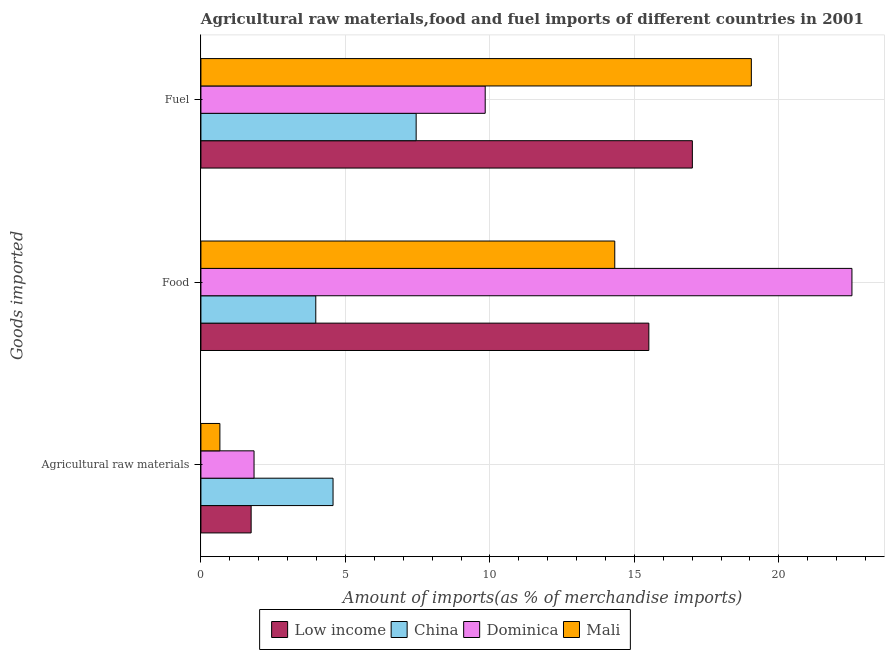How many bars are there on the 2nd tick from the bottom?
Your answer should be very brief. 4. What is the label of the 2nd group of bars from the top?
Your answer should be compact. Food. What is the percentage of food imports in China?
Provide a succinct answer. 3.97. Across all countries, what is the maximum percentage of food imports?
Keep it short and to the point. 22.53. Across all countries, what is the minimum percentage of food imports?
Your answer should be compact. 3.97. In which country was the percentage of food imports maximum?
Offer a terse response. Dominica. What is the total percentage of fuel imports in the graph?
Your response must be concise. 53.34. What is the difference between the percentage of fuel imports in Low income and that in Dominica?
Provide a succinct answer. 7.17. What is the difference between the percentage of fuel imports in Low income and the percentage of food imports in China?
Provide a short and direct response. 13.03. What is the average percentage of fuel imports per country?
Offer a very short reply. 13.33. What is the difference between the percentage of fuel imports and percentage of food imports in Dominica?
Keep it short and to the point. -12.69. What is the ratio of the percentage of fuel imports in Low income to that in China?
Offer a terse response. 2.28. Is the percentage of fuel imports in Dominica less than that in China?
Keep it short and to the point. No. Is the difference between the percentage of raw materials imports in Mali and Low income greater than the difference between the percentage of food imports in Mali and Low income?
Your answer should be compact. Yes. What is the difference between the highest and the second highest percentage of fuel imports?
Your answer should be compact. 2.04. What is the difference between the highest and the lowest percentage of food imports?
Your answer should be very brief. 18.55. Is the sum of the percentage of raw materials imports in China and Dominica greater than the maximum percentage of food imports across all countries?
Your response must be concise. No. What does the 1st bar from the top in Agricultural raw materials represents?
Provide a succinct answer. Mali. What does the 2nd bar from the bottom in Food represents?
Make the answer very short. China. Is it the case that in every country, the sum of the percentage of raw materials imports and percentage of food imports is greater than the percentage of fuel imports?
Your response must be concise. No. How many bars are there?
Your answer should be very brief. 12. Are all the bars in the graph horizontal?
Make the answer very short. Yes. How many countries are there in the graph?
Your answer should be very brief. 4. What is the difference between two consecutive major ticks on the X-axis?
Make the answer very short. 5. Are the values on the major ticks of X-axis written in scientific E-notation?
Give a very brief answer. No. Does the graph contain any zero values?
Keep it short and to the point. No. Does the graph contain grids?
Your answer should be compact. Yes. How are the legend labels stacked?
Keep it short and to the point. Horizontal. What is the title of the graph?
Offer a very short reply. Agricultural raw materials,food and fuel imports of different countries in 2001. What is the label or title of the X-axis?
Provide a short and direct response. Amount of imports(as % of merchandise imports). What is the label or title of the Y-axis?
Ensure brevity in your answer.  Goods imported. What is the Amount of imports(as % of merchandise imports) in Low income in Agricultural raw materials?
Offer a very short reply. 1.74. What is the Amount of imports(as % of merchandise imports) in China in Agricultural raw materials?
Make the answer very short. 4.57. What is the Amount of imports(as % of merchandise imports) in Dominica in Agricultural raw materials?
Make the answer very short. 1.84. What is the Amount of imports(as % of merchandise imports) in Mali in Agricultural raw materials?
Offer a terse response. 0.66. What is the Amount of imports(as % of merchandise imports) in Low income in Food?
Your answer should be very brief. 15.5. What is the Amount of imports(as % of merchandise imports) in China in Food?
Your answer should be very brief. 3.97. What is the Amount of imports(as % of merchandise imports) in Dominica in Food?
Your answer should be compact. 22.53. What is the Amount of imports(as % of merchandise imports) in Mali in Food?
Offer a terse response. 14.32. What is the Amount of imports(as % of merchandise imports) in Low income in Fuel?
Make the answer very short. 17.01. What is the Amount of imports(as % of merchandise imports) in China in Fuel?
Provide a succinct answer. 7.45. What is the Amount of imports(as % of merchandise imports) of Dominica in Fuel?
Offer a terse response. 9.84. What is the Amount of imports(as % of merchandise imports) of Mali in Fuel?
Offer a terse response. 19.05. Across all Goods imported, what is the maximum Amount of imports(as % of merchandise imports) in Low income?
Give a very brief answer. 17.01. Across all Goods imported, what is the maximum Amount of imports(as % of merchandise imports) in China?
Your response must be concise. 7.45. Across all Goods imported, what is the maximum Amount of imports(as % of merchandise imports) in Dominica?
Keep it short and to the point. 22.53. Across all Goods imported, what is the maximum Amount of imports(as % of merchandise imports) of Mali?
Offer a very short reply. 19.05. Across all Goods imported, what is the minimum Amount of imports(as % of merchandise imports) in Low income?
Provide a succinct answer. 1.74. Across all Goods imported, what is the minimum Amount of imports(as % of merchandise imports) of China?
Keep it short and to the point. 3.97. Across all Goods imported, what is the minimum Amount of imports(as % of merchandise imports) in Dominica?
Your response must be concise. 1.84. Across all Goods imported, what is the minimum Amount of imports(as % of merchandise imports) of Mali?
Offer a terse response. 0.66. What is the total Amount of imports(as % of merchandise imports) in Low income in the graph?
Give a very brief answer. 34.24. What is the total Amount of imports(as % of merchandise imports) in China in the graph?
Provide a succinct answer. 16. What is the total Amount of imports(as % of merchandise imports) in Dominica in the graph?
Your response must be concise. 34.2. What is the total Amount of imports(as % of merchandise imports) in Mali in the graph?
Your answer should be very brief. 34.02. What is the difference between the Amount of imports(as % of merchandise imports) of Low income in Agricultural raw materials and that in Food?
Keep it short and to the point. -13.76. What is the difference between the Amount of imports(as % of merchandise imports) in China in Agricultural raw materials and that in Food?
Give a very brief answer. 0.6. What is the difference between the Amount of imports(as % of merchandise imports) in Dominica in Agricultural raw materials and that in Food?
Provide a short and direct response. -20.69. What is the difference between the Amount of imports(as % of merchandise imports) of Mali in Agricultural raw materials and that in Food?
Keep it short and to the point. -13.66. What is the difference between the Amount of imports(as % of merchandise imports) in Low income in Agricultural raw materials and that in Fuel?
Make the answer very short. -15.27. What is the difference between the Amount of imports(as % of merchandise imports) of China in Agricultural raw materials and that in Fuel?
Ensure brevity in your answer.  -2.88. What is the difference between the Amount of imports(as % of merchandise imports) in Dominica in Agricultural raw materials and that in Fuel?
Your answer should be very brief. -8. What is the difference between the Amount of imports(as % of merchandise imports) in Mali in Agricultural raw materials and that in Fuel?
Keep it short and to the point. -18.39. What is the difference between the Amount of imports(as % of merchandise imports) in Low income in Food and that in Fuel?
Provide a short and direct response. -1.51. What is the difference between the Amount of imports(as % of merchandise imports) of China in Food and that in Fuel?
Provide a short and direct response. -3.47. What is the difference between the Amount of imports(as % of merchandise imports) of Dominica in Food and that in Fuel?
Make the answer very short. 12.69. What is the difference between the Amount of imports(as % of merchandise imports) in Mali in Food and that in Fuel?
Ensure brevity in your answer.  -4.73. What is the difference between the Amount of imports(as % of merchandise imports) of Low income in Agricultural raw materials and the Amount of imports(as % of merchandise imports) of China in Food?
Ensure brevity in your answer.  -2.24. What is the difference between the Amount of imports(as % of merchandise imports) of Low income in Agricultural raw materials and the Amount of imports(as % of merchandise imports) of Dominica in Food?
Ensure brevity in your answer.  -20.79. What is the difference between the Amount of imports(as % of merchandise imports) of Low income in Agricultural raw materials and the Amount of imports(as % of merchandise imports) of Mali in Food?
Give a very brief answer. -12.58. What is the difference between the Amount of imports(as % of merchandise imports) of China in Agricultural raw materials and the Amount of imports(as % of merchandise imports) of Dominica in Food?
Make the answer very short. -17.96. What is the difference between the Amount of imports(as % of merchandise imports) in China in Agricultural raw materials and the Amount of imports(as % of merchandise imports) in Mali in Food?
Your answer should be compact. -9.75. What is the difference between the Amount of imports(as % of merchandise imports) of Dominica in Agricultural raw materials and the Amount of imports(as % of merchandise imports) of Mali in Food?
Ensure brevity in your answer.  -12.48. What is the difference between the Amount of imports(as % of merchandise imports) in Low income in Agricultural raw materials and the Amount of imports(as % of merchandise imports) in China in Fuel?
Provide a succinct answer. -5.71. What is the difference between the Amount of imports(as % of merchandise imports) in Low income in Agricultural raw materials and the Amount of imports(as % of merchandise imports) in Dominica in Fuel?
Your response must be concise. -8.1. What is the difference between the Amount of imports(as % of merchandise imports) of Low income in Agricultural raw materials and the Amount of imports(as % of merchandise imports) of Mali in Fuel?
Your response must be concise. -17.31. What is the difference between the Amount of imports(as % of merchandise imports) in China in Agricultural raw materials and the Amount of imports(as % of merchandise imports) in Dominica in Fuel?
Offer a very short reply. -5.27. What is the difference between the Amount of imports(as % of merchandise imports) in China in Agricultural raw materials and the Amount of imports(as % of merchandise imports) in Mali in Fuel?
Your answer should be compact. -14.47. What is the difference between the Amount of imports(as % of merchandise imports) in Dominica in Agricultural raw materials and the Amount of imports(as % of merchandise imports) in Mali in Fuel?
Your answer should be compact. -17.21. What is the difference between the Amount of imports(as % of merchandise imports) of Low income in Food and the Amount of imports(as % of merchandise imports) of China in Fuel?
Your answer should be compact. 8.05. What is the difference between the Amount of imports(as % of merchandise imports) of Low income in Food and the Amount of imports(as % of merchandise imports) of Dominica in Fuel?
Give a very brief answer. 5.66. What is the difference between the Amount of imports(as % of merchandise imports) in Low income in Food and the Amount of imports(as % of merchandise imports) in Mali in Fuel?
Your answer should be compact. -3.55. What is the difference between the Amount of imports(as % of merchandise imports) in China in Food and the Amount of imports(as % of merchandise imports) in Dominica in Fuel?
Give a very brief answer. -5.86. What is the difference between the Amount of imports(as % of merchandise imports) in China in Food and the Amount of imports(as % of merchandise imports) in Mali in Fuel?
Give a very brief answer. -15.07. What is the difference between the Amount of imports(as % of merchandise imports) of Dominica in Food and the Amount of imports(as % of merchandise imports) of Mali in Fuel?
Keep it short and to the point. 3.48. What is the average Amount of imports(as % of merchandise imports) in Low income per Goods imported?
Provide a short and direct response. 11.41. What is the average Amount of imports(as % of merchandise imports) in China per Goods imported?
Provide a succinct answer. 5.33. What is the average Amount of imports(as % of merchandise imports) in Dominica per Goods imported?
Offer a very short reply. 11.4. What is the average Amount of imports(as % of merchandise imports) in Mali per Goods imported?
Keep it short and to the point. 11.34. What is the difference between the Amount of imports(as % of merchandise imports) in Low income and Amount of imports(as % of merchandise imports) in China in Agricultural raw materials?
Offer a very short reply. -2.83. What is the difference between the Amount of imports(as % of merchandise imports) of Low income and Amount of imports(as % of merchandise imports) of Dominica in Agricultural raw materials?
Your answer should be very brief. -0.1. What is the difference between the Amount of imports(as % of merchandise imports) of Low income and Amount of imports(as % of merchandise imports) of Mali in Agricultural raw materials?
Provide a succinct answer. 1.08. What is the difference between the Amount of imports(as % of merchandise imports) of China and Amount of imports(as % of merchandise imports) of Dominica in Agricultural raw materials?
Your answer should be very brief. 2.73. What is the difference between the Amount of imports(as % of merchandise imports) in China and Amount of imports(as % of merchandise imports) in Mali in Agricultural raw materials?
Offer a very short reply. 3.92. What is the difference between the Amount of imports(as % of merchandise imports) of Dominica and Amount of imports(as % of merchandise imports) of Mali in Agricultural raw materials?
Ensure brevity in your answer.  1.18. What is the difference between the Amount of imports(as % of merchandise imports) in Low income and Amount of imports(as % of merchandise imports) in China in Food?
Your answer should be very brief. 11.53. What is the difference between the Amount of imports(as % of merchandise imports) in Low income and Amount of imports(as % of merchandise imports) in Dominica in Food?
Ensure brevity in your answer.  -7.03. What is the difference between the Amount of imports(as % of merchandise imports) of Low income and Amount of imports(as % of merchandise imports) of Mali in Food?
Ensure brevity in your answer.  1.18. What is the difference between the Amount of imports(as % of merchandise imports) of China and Amount of imports(as % of merchandise imports) of Dominica in Food?
Your answer should be very brief. -18.55. What is the difference between the Amount of imports(as % of merchandise imports) in China and Amount of imports(as % of merchandise imports) in Mali in Food?
Offer a very short reply. -10.35. What is the difference between the Amount of imports(as % of merchandise imports) in Dominica and Amount of imports(as % of merchandise imports) in Mali in Food?
Offer a terse response. 8.21. What is the difference between the Amount of imports(as % of merchandise imports) in Low income and Amount of imports(as % of merchandise imports) in China in Fuel?
Ensure brevity in your answer.  9.56. What is the difference between the Amount of imports(as % of merchandise imports) in Low income and Amount of imports(as % of merchandise imports) in Dominica in Fuel?
Give a very brief answer. 7.17. What is the difference between the Amount of imports(as % of merchandise imports) of Low income and Amount of imports(as % of merchandise imports) of Mali in Fuel?
Keep it short and to the point. -2.04. What is the difference between the Amount of imports(as % of merchandise imports) in China and Amount of imports(as % of merchandise imports) in Dominica in Fuel?
Give a very brief answer. -2.39. What is the difference between the Amount of imports(as % of merchandise imports) of China and Amount of imports(as % of merchandise imports) of Mali in Fuel?
Your answer should be compact. -11.6. What is the difference between the Amount of imports(as % of merchandise imports) of Dominica and Amount of imports(as % of merchandise imports) of Mali in Fuel?
Keep it short and to the point. -9.21. What is the ratio of the Amount of imports(as % of merchandise imports) in Low income in Agricultural raw materials to that in Food?
Provide a short and direct response. 0.11. What is the ratio of the Amount of imports(as % of merchandise imports) in China in Agricultural raw materials to that in Food?
Your response must be concise. 1.15. What is the ratio of the Amount of imports(as % of merchandise imports) in Dominica in Agricultural raw materials to that in Food?
Offer a very short reply. 0.08. What is the ratio of the Amount of imports(as % of merchandise imports) in Mali in Agricultural raw materials to that in Food?
Offer a very short reply. 0.05. What is the ratio of the Amount of imports(as % of merchandise imports) of Low income in Agricultural raw materials to that in Fuel?
Your response must be concise. 0.1. What is the ratio of the Amount of imports(as % of merchandise imports) in China in Agricultural raw materials to that in Fuel?
Your response must be concise. 0.61. What is the ratio of the Amount of imports(as % of merchandise imports) in Dominica in Agricultural raw materials to that in Fuel?
Make the answer very short. 0.19. What is the ratio of the Amount of imports(as % of merchandise imports) in Mali in Agricultural raw materials to that in Fuel?
Provide a short and direct response. 0.03. What is the ratio of the Amount of imports(as % of merchandise imports) in Low income in Food to that in Fuel?
Provide a succinct answer. 0.91. What is the ratio of the Amount of imports(as % of merchandise imports) of China in Food to that in Fuel?
Keep it short and to the point. 0.53. What is the ratio of the Amount of imports(as % of merchandise imports) of Dominica in Food to that in Fuel?
Ensure brevity in your answer.  2.29. What is the ratio of the Amount of imports(as % of merchandise imports) in Mali in Food to that in Fuel?
Provide a succinct answer. 0.75. What is the difference between the highest and the second highest Amount of imports(as % of merchandise imports) of Low income?
Offer a very short reply. 1.51. What is the difference between the highest and the second highest Amount of imports(as % of merchandise imports) in China?
Give a very brief answer. 2.88. What is the difference between the highest and the second highest Amount of imports(as % of merchandise imports) in Dominica?
Make the answer very short. 12.69. What is the difference between the highest and the second highest Amount of imports(as % of merchandise imports) of Mali?
Give a very brief answer. 4.73. What is the difference between the highest and the lowest Amount of imports(as % of merchandise imports) in Low income?
Your response must be concise. 15.27. What is the difference between the highest and the lowest Amount of imports(as % of merchandise imports) in China?
Make the answer very short. 3.47. What is the difference between the highest and the lowest Amount of imports(as % of merchandise imports) in Dominica?
Your response must be concise. 20.69. What is the difference between the highest and the lowest Amount of imports(as % of merchandise imports) in Mali?
Keep it short and to the point. 18.39. 